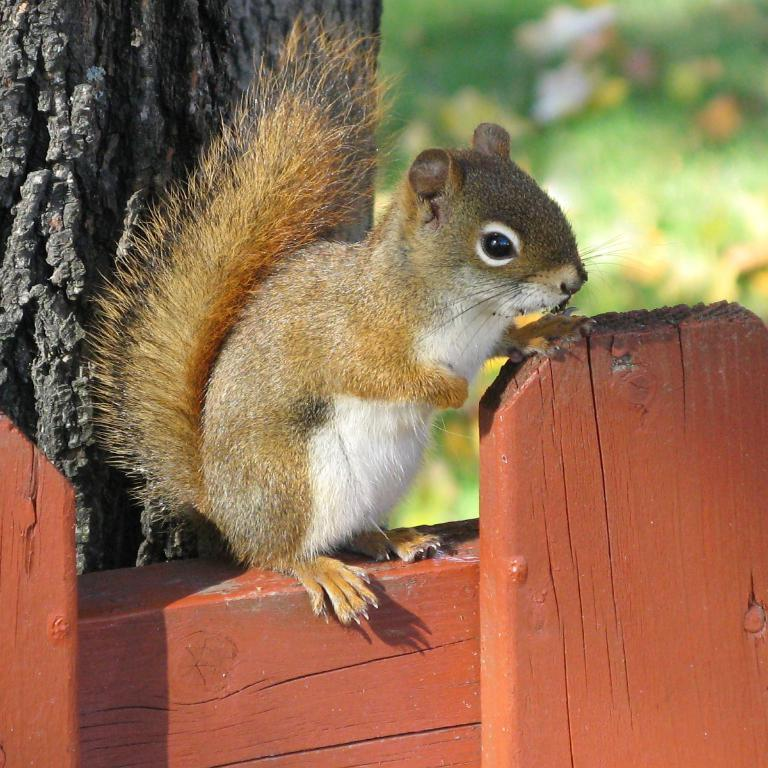What animal is present in the image? There is a squirrel in the image. Can you describe the background of the image? The background of the image is blurry. What disease does the squirrel have in the image? There is no indication of any disease in the image; the squirrel appears to be healthy. What is the squirrel learning in the image? There is no indication of the squirrel learning anything in the image; it is simply present in the scene. 